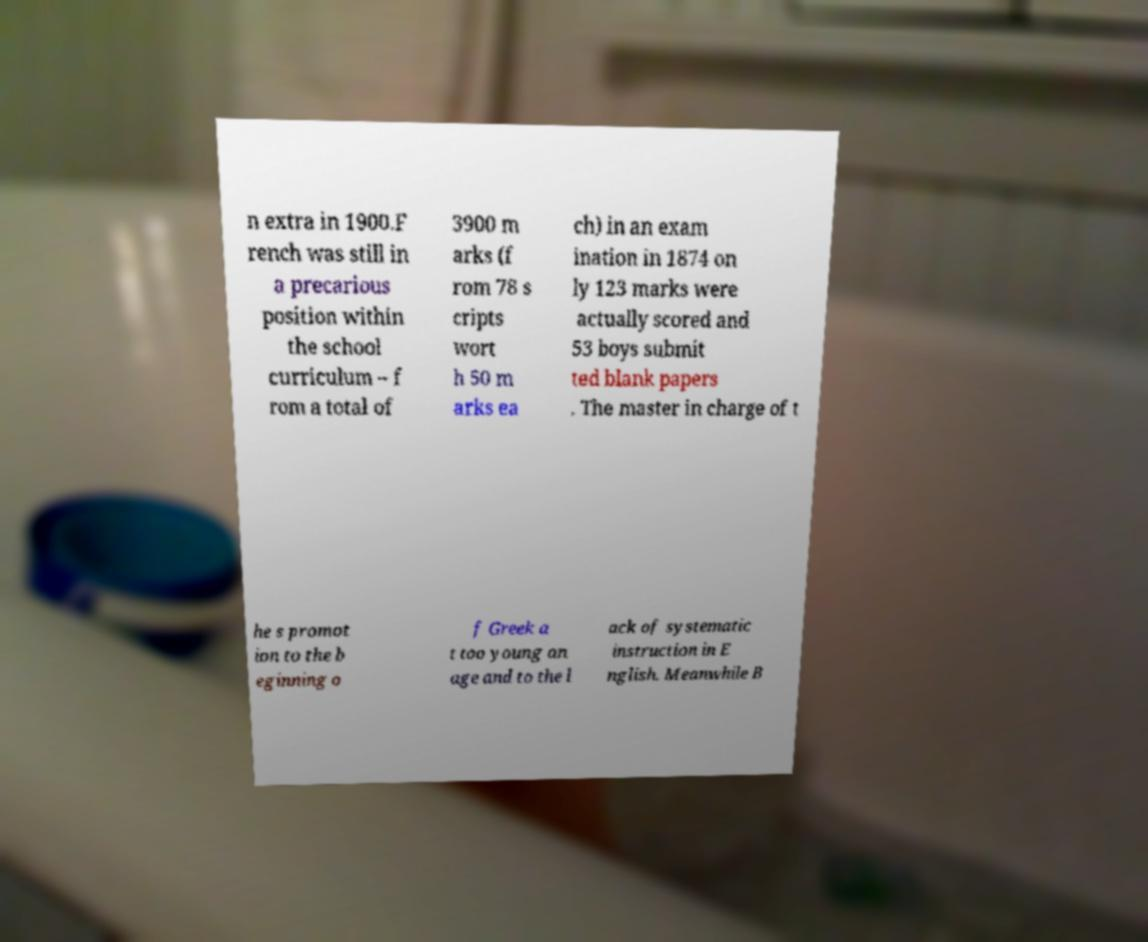Please read and relay the text visible in this image. What does it say? n extra in 1900.F rench was still in a precarious position within the school curriculum – f rom a total of 3900 m arks (f rom 78 s cripts wort h 50 m arks ea ch) in an exam ination in 1874 on ly 123 marks were actually scored and 53 boys submit ted blank papers . The master in charge of t he s promot ion to the b eginning o f Greek a t too young an age and to the l ack of systematic instruction in E nglish. Meanwhile B 